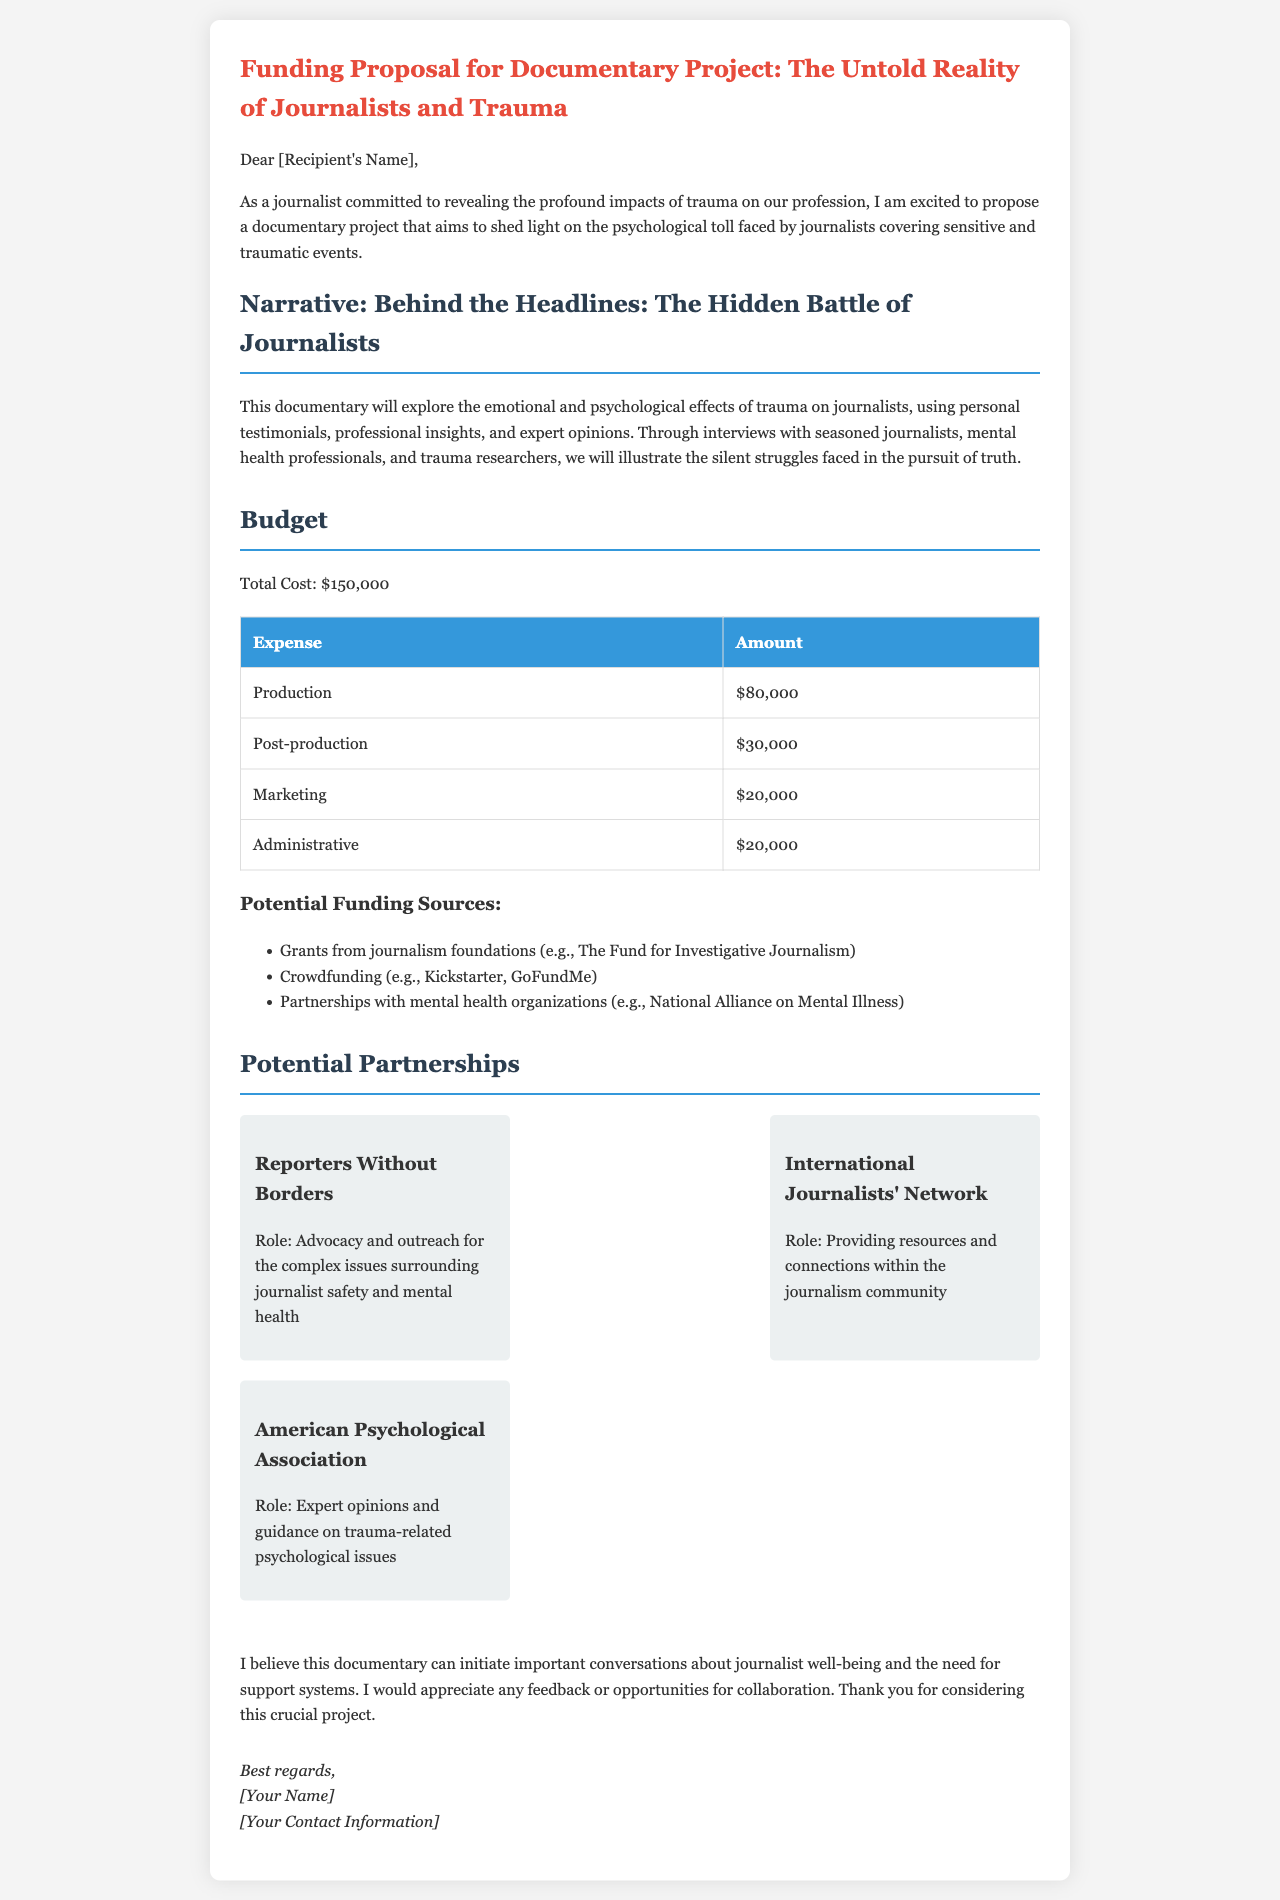What is the total cost of the project? The total cost is explicitly stated in the budget section of the document as $150,000.
Answer: $150,000 Who is the recipient of the proposal addressed to? The document indicates [Recipient's Name] in the greeting, suggesting it is customizable for different recipients.
Answer: [Recipient's Name] What is the title of the documentary? The title of the documentary is given at the top of the document.
Answer: The Untold Reality of Journalists and Trauma Which organization is focused on advocacy and outreach for journalist safety? This information is found in the partnerships section of the document.
Answer: Reporters Without Borders How much is allocated for post-production? This is listed in the budget table under the corresponding expense category.
Answer: $30,000 What is the role of the American Psychological Association in the project? The document specifies this role in the potential partnerships section.
Answer: Expert opinions and guidance on trauma-related psychological issues What type of funding does the proposal suggest using besides grants? The document mentions alternative funding sources under the budget section.
Answer: Crowdfunding What is the main focus of the documentary's narrative? This is described in the narrative section of the document.
Answer: The emotional and psychological effects of trauma on journalists 